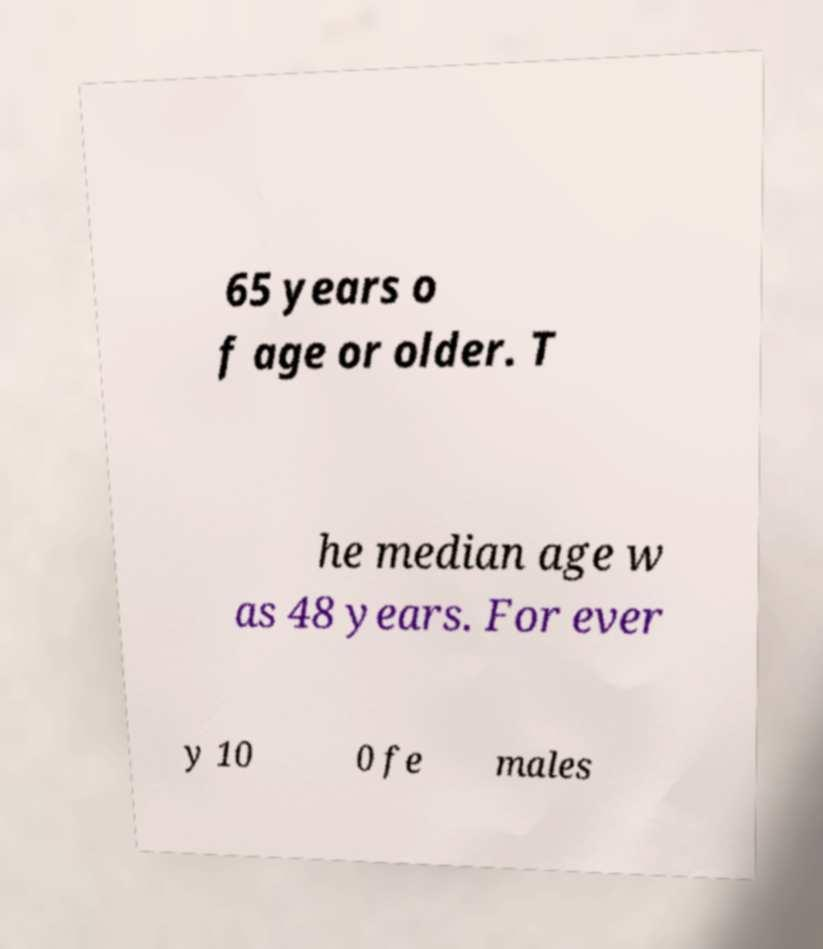Could you assist in decoding the text presented in this image and type it out clearly? 65 years o f age or older. T he median age w as 48 years. For ever y 10 0 fe males 